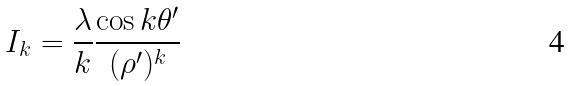<formula> <loc_0><loc_0><loc_500><loc_500>I _ { k } = \frac { \lambda } { k } \frac { \cos k \theta ^ { \prime } } { ( \rho ^ { \prime } ) ^ { k } }</formula> 